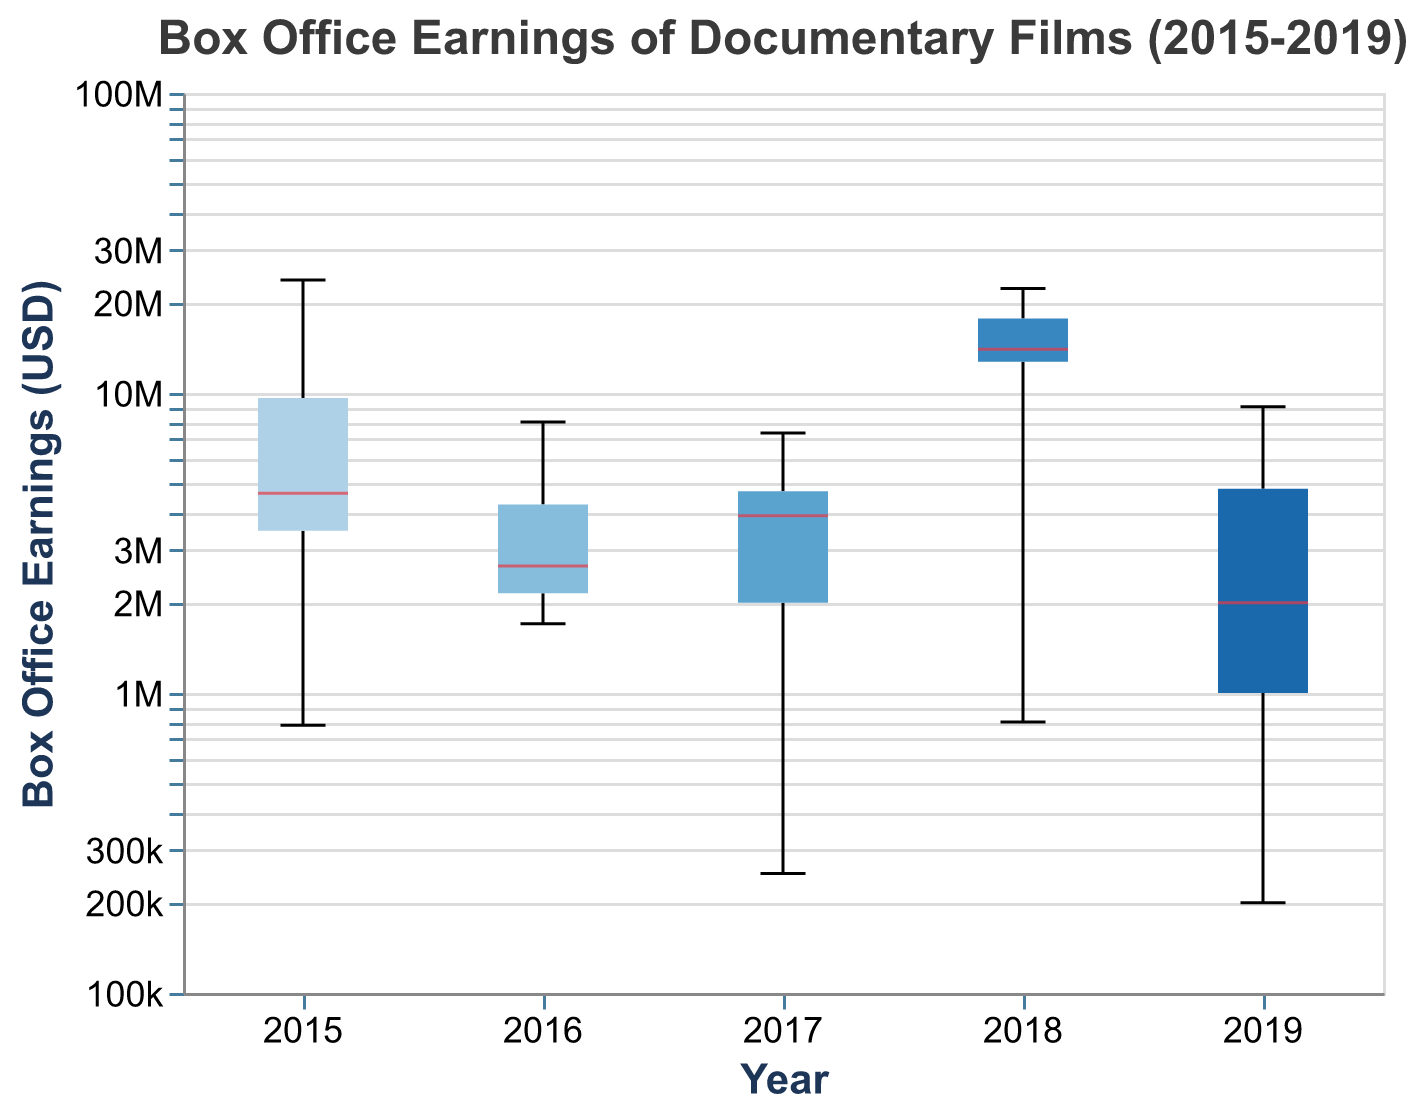What's the title of the chart? The title is displayed at the top of the chart in a larger font size.
Answer: Box Office Earnings of Documentary Films (2015-2019) What is the highest box office earning in 2018? The highest box office earning for 2018 can be found by looking at the upper whisker or outlier in the box plot for 2018.
Answer: 22300000 Which year has the lowest median box office earnings? The median value for each year is indicated by a line inside the box plot. The year with the lowest median can be visually identified.
Answer: 2015 What is the range of box office earnings for 2017? The range is calculated by subtracting the minimum value (bottom whisker or lowest data point) from the maximum value (top whisker or highest data point) for 2017.
Answer: 250000 to 7360000 How many documentaries have box office earnings above $10 million in 2018? Count the number of outliers or data points above 10000000 in the box plot for 2018.
Answer: 3 Which year has the widest interquartile range (IQR)? The IQR is the height of the box in the box plot, representing the middle 50% of the data. Visually compare the height of the boxes for all years.
Answer: 2018 Are there any outliers in 2019? Outliers are shown as dots or individual points separate from the whiskers and box. Look for any such points in the 2019 box plot.
Answer: Yes Compare the median box office earnings between 2016 and 2017. Which year is higher? The median value is indicated by a line within each box. Compare the positions of these lines for 2016 and 2017.
Answer: 2017 What can you infer about the box office earnings trends for documentaries from 2015 to 2019? Examine the general position of the boxes and median lines across years to observe any trends in box office earnings over the years.
Answer: Increasing trend with higher variability in later years 